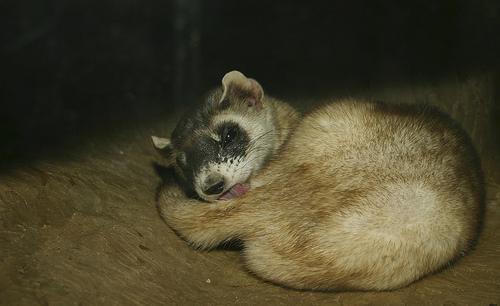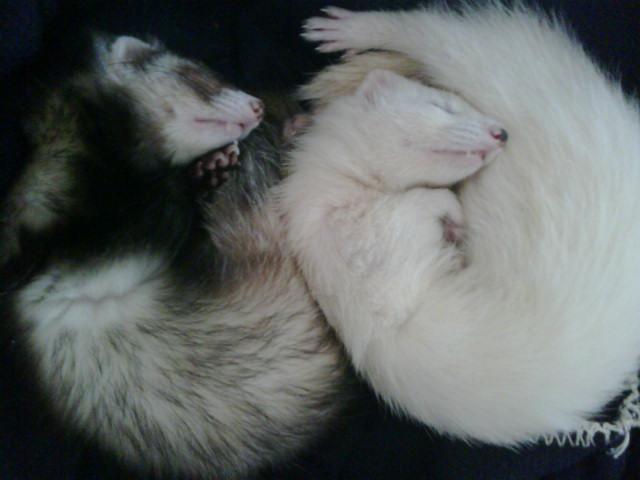The first image is the image on the left, the second image is the image on the right. Evaluate the accuracy of this statement regarding the images: "There are a total of three ferrets.". Is it true? Answer yes or no. Yes. 